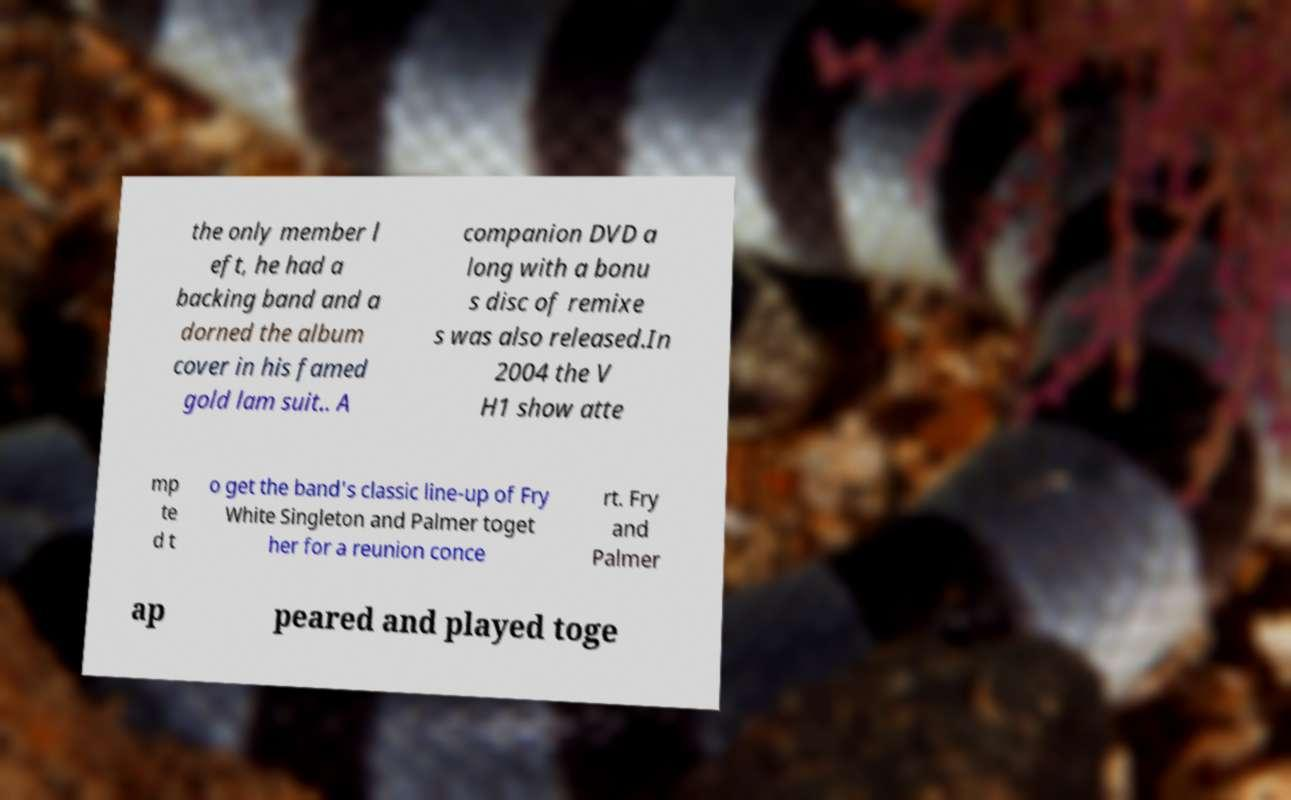Could you assist in decoding the text presented in this image and type it out clearly? the only member l eft, he had a backing band and a dorned the album cover in his famed gold lam suit.. A companion DVD a long with a bonu s disc of remixe s was also released.In 2004 the V H1 show atte mp te d t o get the band's classic line-up of Fry White Singleton and Palmer toget her for a reunion conce rt. Fry and Palmer ap peared and played toge 